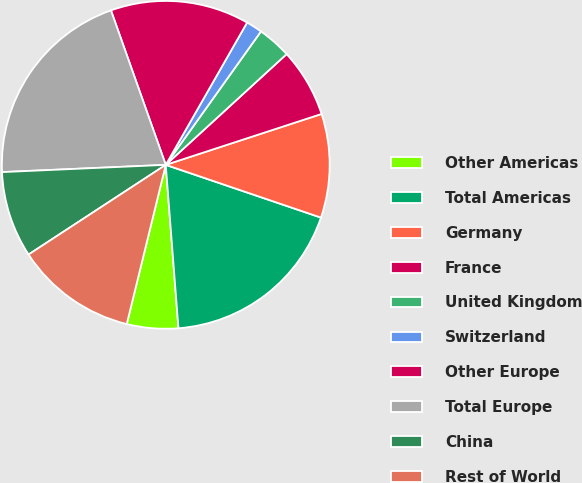Convert chart. <chart><loc_0><loc_0><loc_500><loc_500><pie_chart><fcel>Other Americas<fcel>Total Americas<fcel>Germany<fcel>France<fcel>United Kingdom<fcel>Switzerland<fcel>Other Europe<fcel>Total Europe<fcel>China<fcel>Rest of World<nl><fcel>5.06%<fcel>18.55%<fcel>10.24%<fcel>6.78%<fcel>3.33%<fcel>1.6%<fcel>13.69%<fcel>20.28%<fcel>8.51%<fcel>11.96%<nl></chart> 